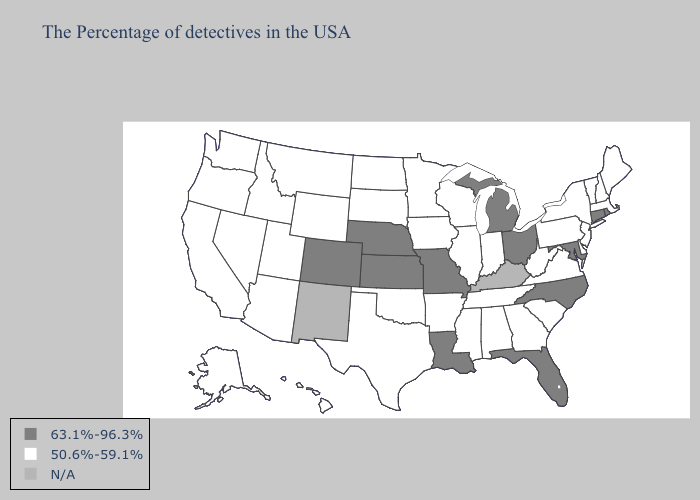Among the states that border Oregon , which have the lowest value?
Write a very short answer. Idaho, Nevada, California, Washington. Among the states that border New Mexico , does Texas have the highest value?
Short answer required. No. Name the states that have a value in the range 63.1%-96.3%?
Quick response, please. Rhode Island, Connecticut, Maryland, North Carolina, Ohio, Florida, Michigan, Louisiana, Missouri, Kansas, Nebraska, Colorado. Name the states that have a value in the range 63.1%-96.3%?
Quick response, please. Rhode Island, Connecticut, Maryland, North Carolina, Ohio, Florida, Michigan, Louisiana, Missouri, Kansas, Nebraska, Colorado. What is the value of Nebraska?
Short answer required. 63.1%-96.3%. How many symbols are there in the legend?
Write a very short answer. 3. Name the states that have a value in the range N/A?
Keep it brief. Kentucky, New Mexico. Name the states that have a value in the range 63.1%-96.3%?
Short answer required. Rhode Island, Connecticut, Maryland, North Carolina, Ohio, Florida, Michigan, Louisiana, Missouri, Kansas, Nebraska, Colorado. Which states hav the highest value in the MidWest?
Concise answer only. Ohio, Michigan, Missouri, Kansas, Nebraska. What is the highest value in the USA?
Answer briefly. 63.1%-96.3%. Does Utah have the highest value in the USA?
Be succinct. No. What is the highest value in the USA?
Answer briefly. 63.1%-96.3%. Name the states that have a value in the range 63.1%-96.3%?
Keep it brief. Rhode Island, Connecticut, Maryland, North Carolina, Ohio, Florida, Michigan, Louisiana, Missouri, Kansas, Nebraska, Colorado. 